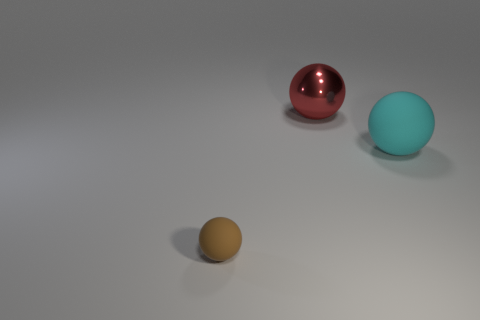Add 2 big metallic things. How many objects exist? 5 Add 1 large objects. How many large objects are left? 3 Add 3 large balls. How many large balls exist? 5 Subtract 0 blue balls. How many objects are left? 3 Subtract all red objects. Subtract all big green rubber blocks. How many objects are left? 2 